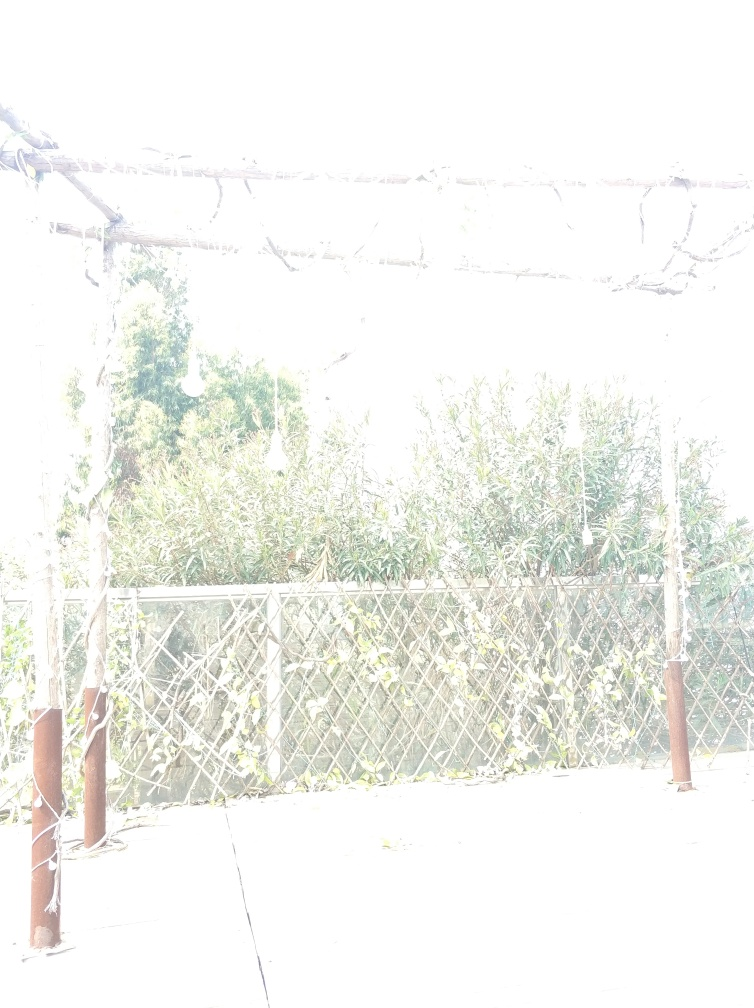Is there any way to fix an overexposed image like this? Post-processing software can be used to correct mildly overexposed images by adjusting the exposure levels, highlights, and shadows. However, in extreme cases like this where details are completely washed out, recovery might not be possible without the original data from a raw file, if it exists. It's always best to get the exposure right in-camera whenever possible. 